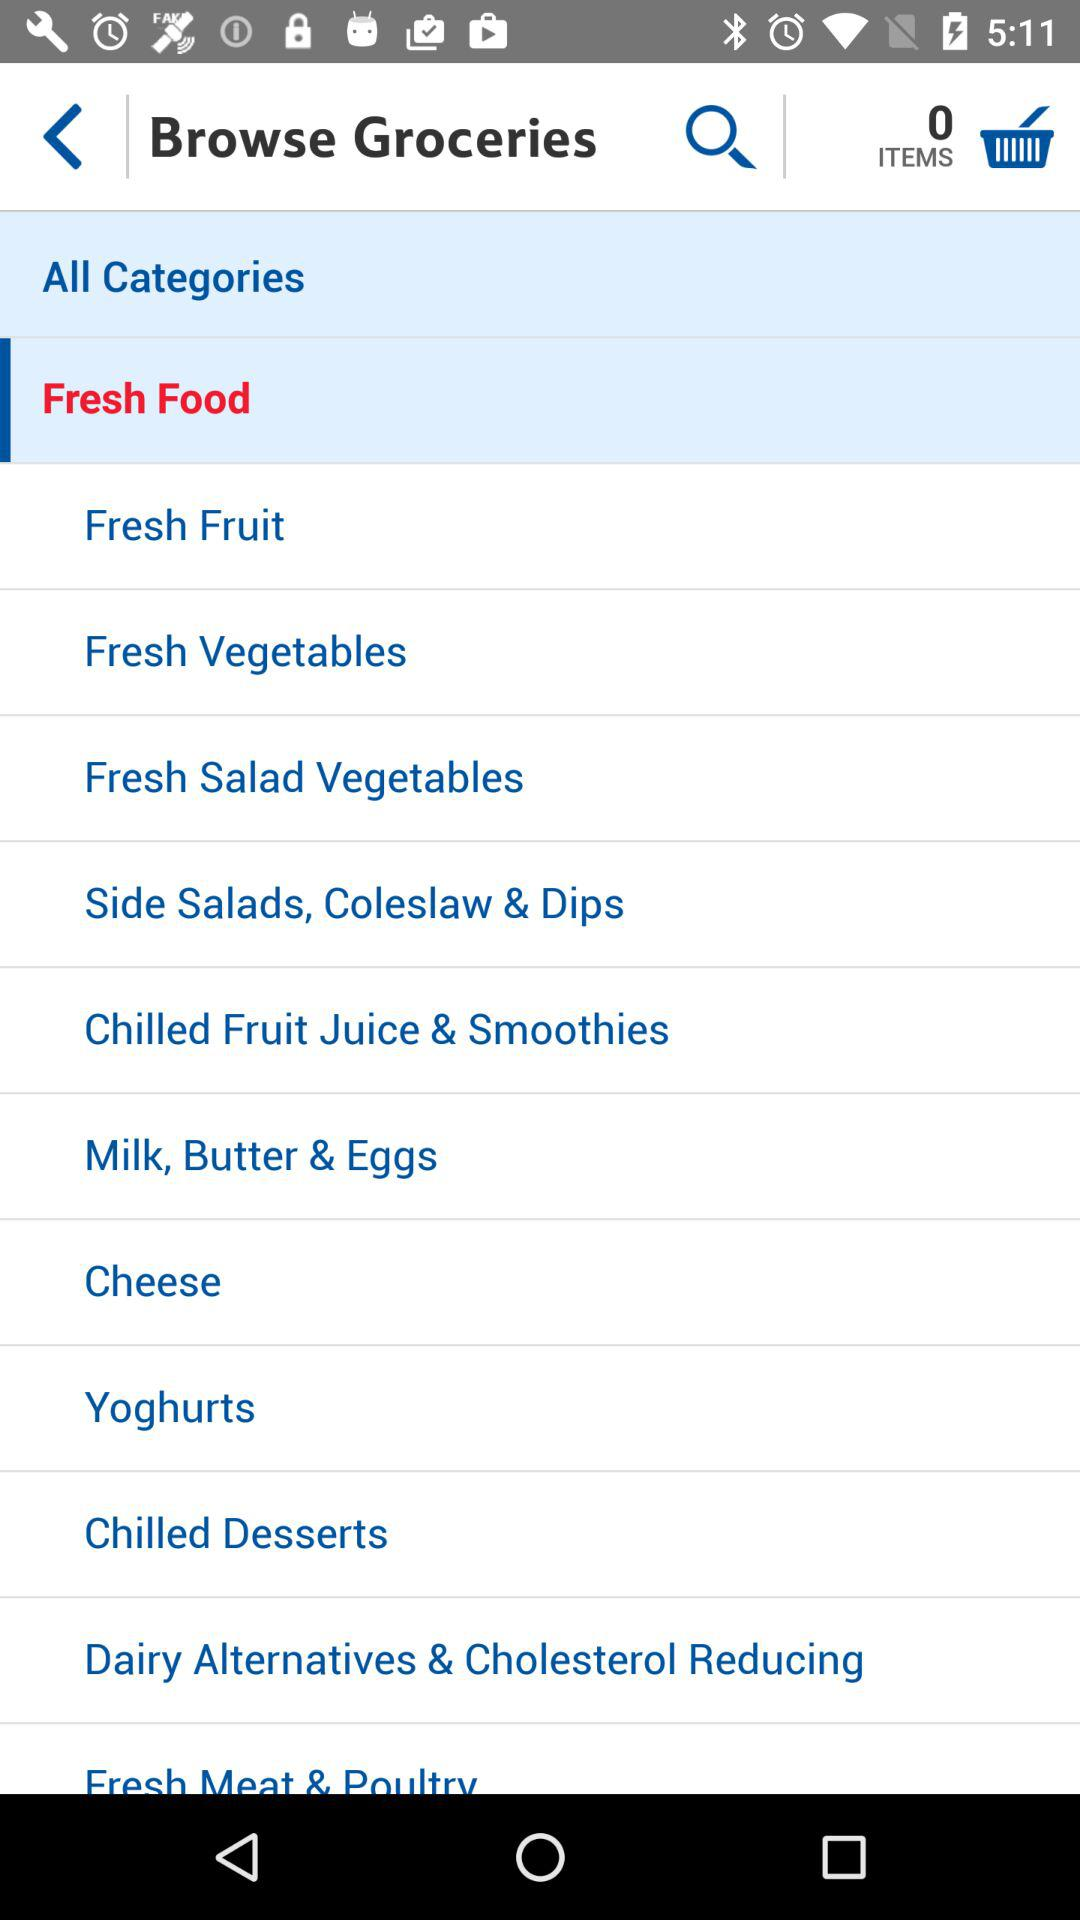What is the selected category? The selected category is fresh food. 